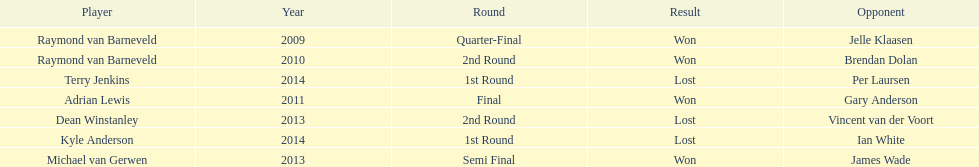Who was the last to win against his opponent? Michael van Gerwen. 